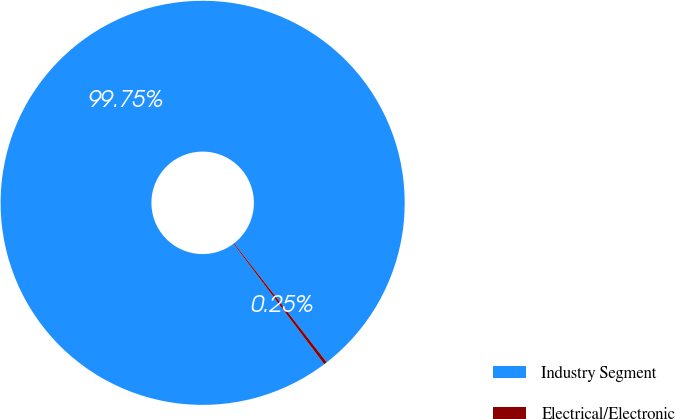Convert chart to OTSL. <chart><loc_0><loc_0><loc_500><loc_500><pie_chart><fcel>Industry Segment<fcel>Electrical/Electronic<nl><fcel>99.75%<fcel>0.25%<nl></chart> 